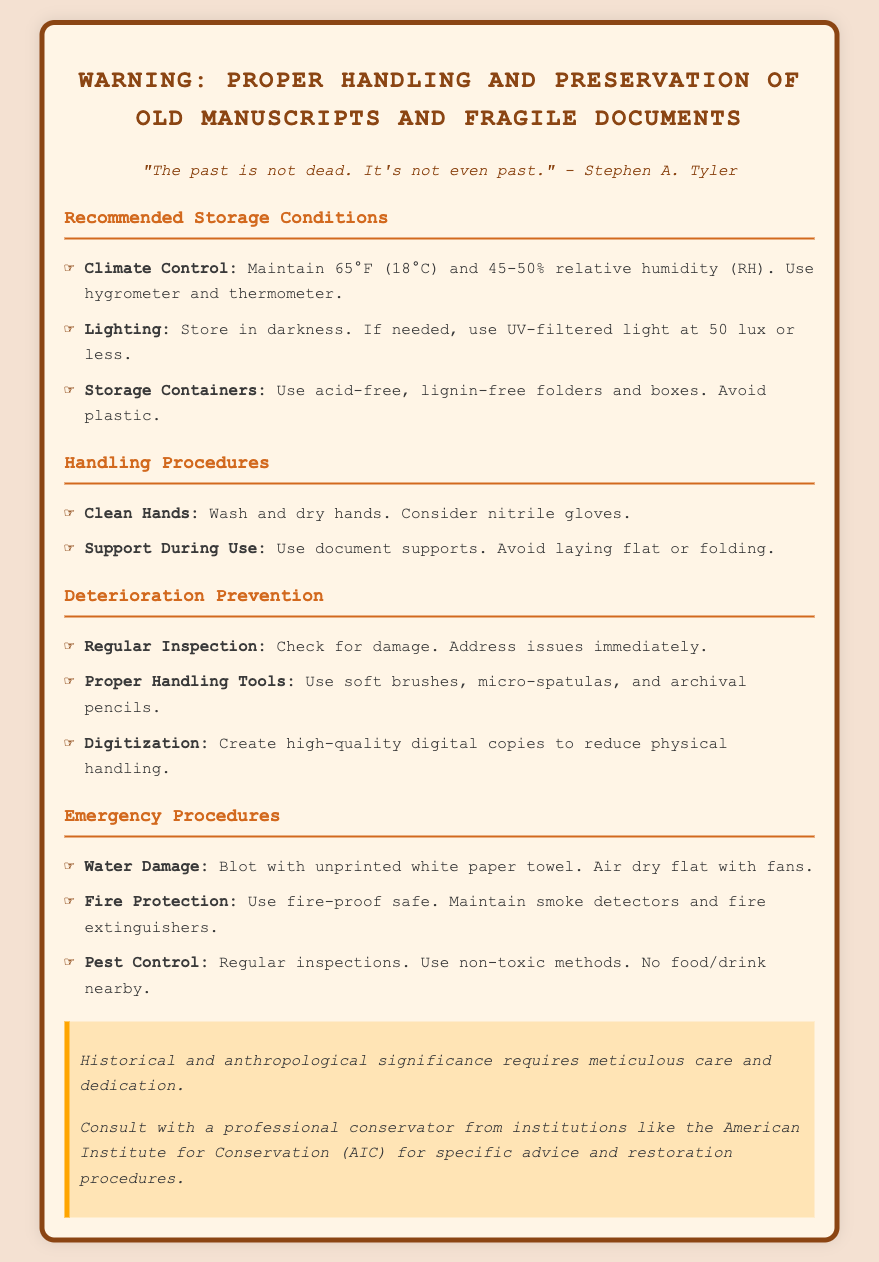what is the recommended temperature for storage? The document states that the recommended temperature for storage is 65°F (18°C).
Answer: 65°F (18°C) what is the ideal relative humidity range for preserving manuscripts? The document mentions that the ideal relative humidity range is 45-50% RH.
Answer: 45-50% RH what should be used to support documents during use? The document advises using document supports to avoid laying flat or folding.
Answer: document supports what type of containers should be used for storage? The document recommends using acid-free, lignin-free folders and boxes, avoiding plastic.
Answer: acid-free, lignin-free folders and boxes how often should inspections for damage occur? The document implies that regular inspections should be conducted to check for damage.
Answer: Regularly why is digitization recommended in handling procedures? The document states that digitization creates high-quality digital copies to reduce physical handling.
Answer: to reduce physical handling what is the emergency procedure for water damage? The document states to blot with unprinted white paper towel and air dry flat with fans.
Answer: Blot with unprinted white paper towel what is a key focus of the special notes section? The special notes section emphasizes the need for meticulous care due to historical and anthropological significance.
Answer: meticulous care what type of gloves are suggested for handling? The document mentions considering nitrile gloves for handling manuscripts.
Answer: nitrile gloves 